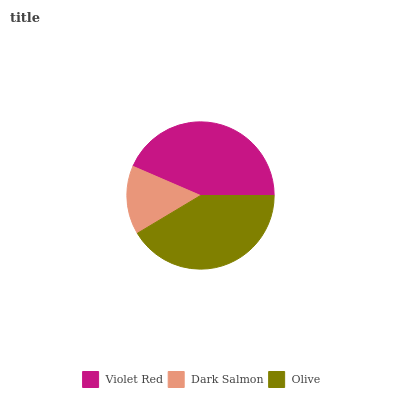Is Dark Salmon the minimum?
Answer yes or no. Yes. Is Violet Red the maximum?
Answer yes or no. Yes. Is Olive the minimum?
Answer yes or no. No. Is Olive the maximum?
Answer yes or no. No. Is Olive greater than Dark Salmon?
Answer yes or no. Yes. Is Dark Salmon less than Olive?
Answer yes or no. Yes. Is Dark Salmon greater than Olive?
Answer yes or no. No. Is Olive less than Dark Salmon?
Answer yes or no. No. Is Olive the high median?
Answer yes or no. Yes. Is Olive the low median?
Answer yes or no. Yes. Is Dark Salmon the high median?
Answer yes or no. No. Is Violet Red the low median?
Answer yes or no. No. 